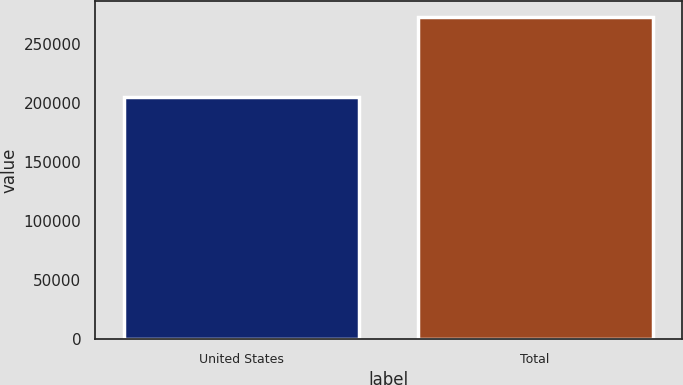<chart> <loc_0><loc_0><loc_500><loc_500><bar_chart><fcel>United States<fcel>Total<nl><fcel>205148<fcel>273153<nl></chart> 